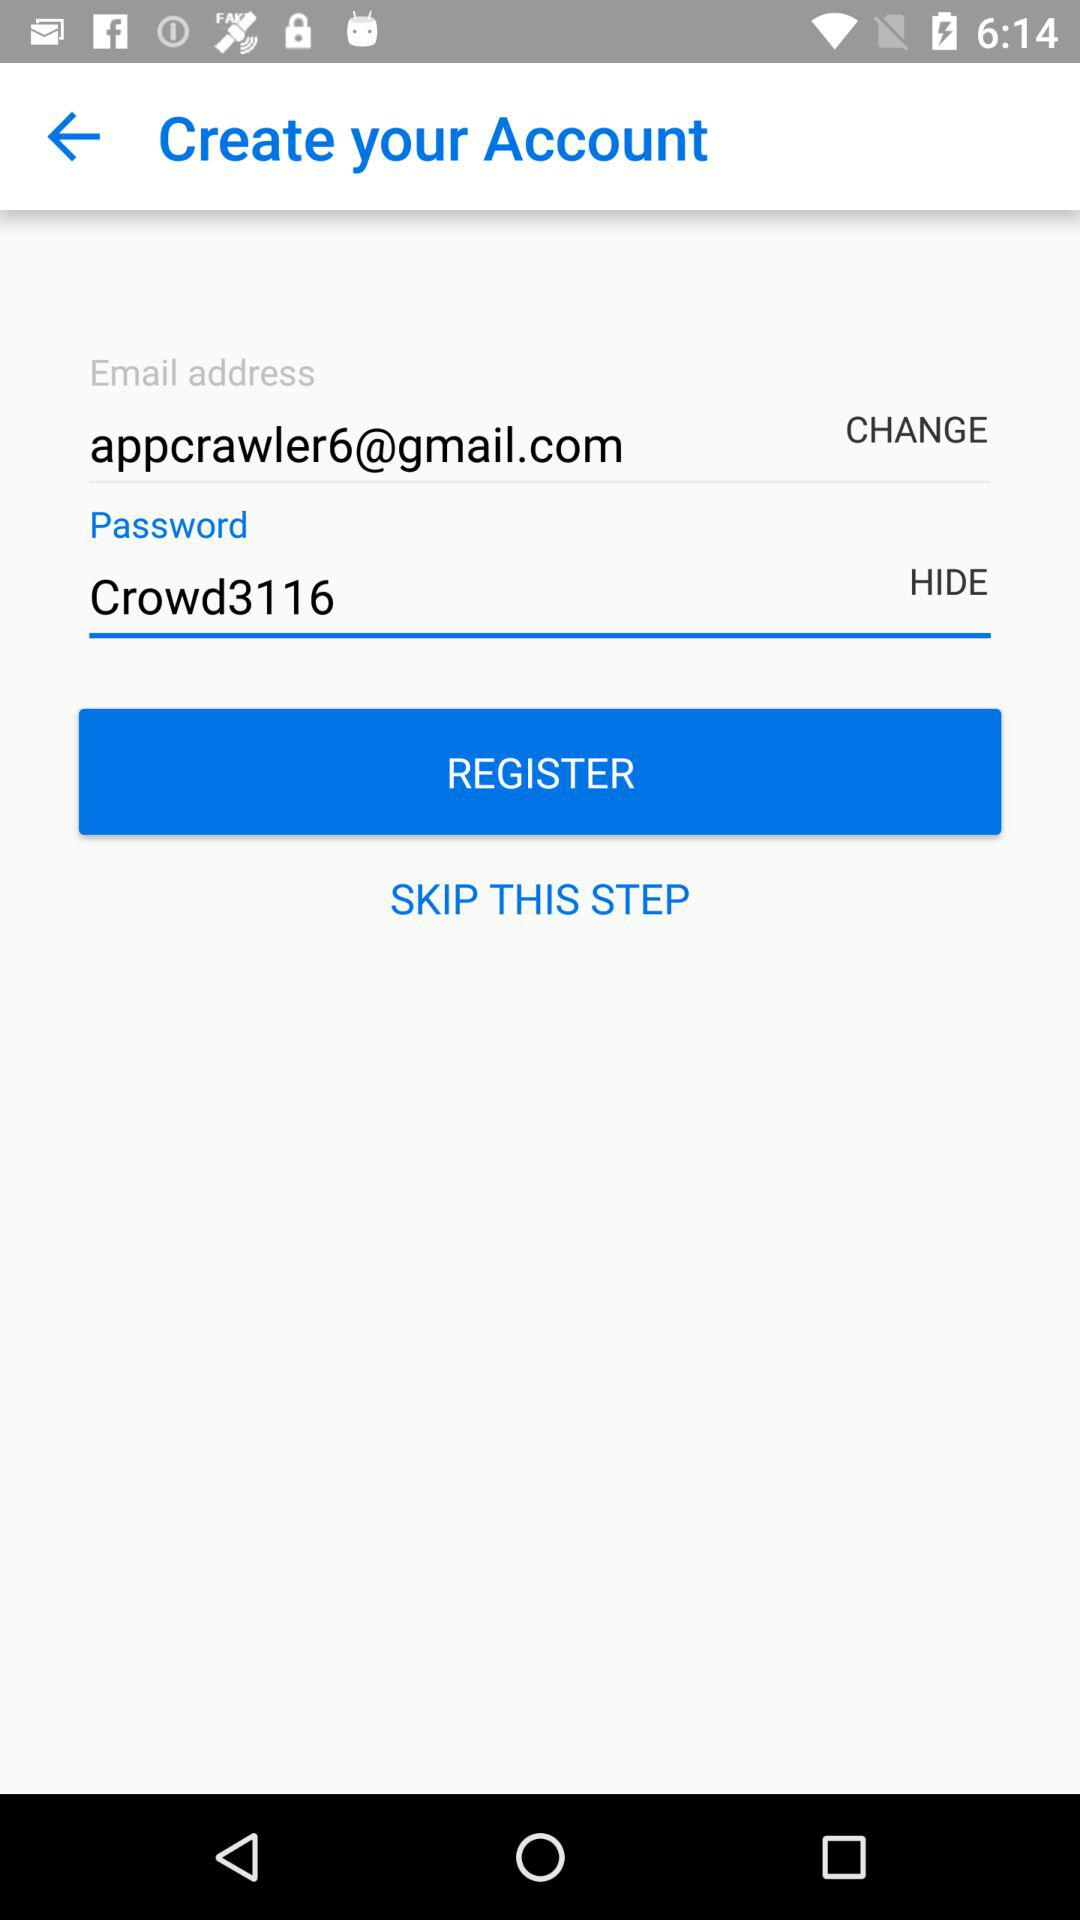What is the password? The password is "Crowd3116". 